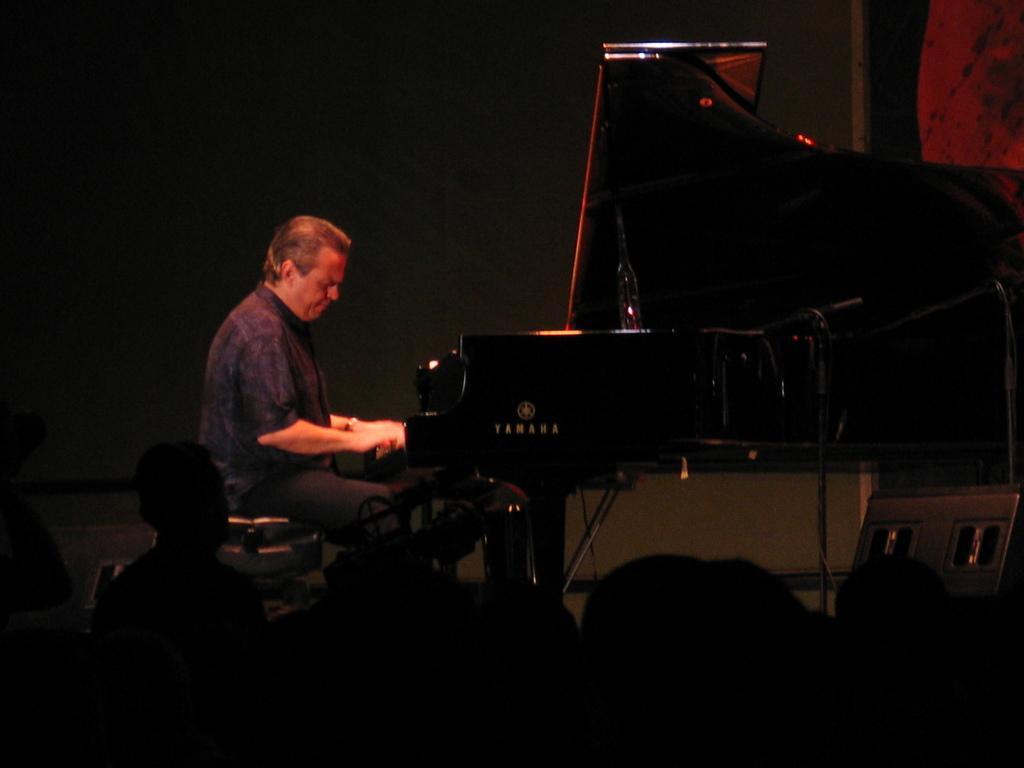Can you describe this image briefly? in this picture a person sitting on the table and playing piano which is in front of him, we can also see some people watching him. 